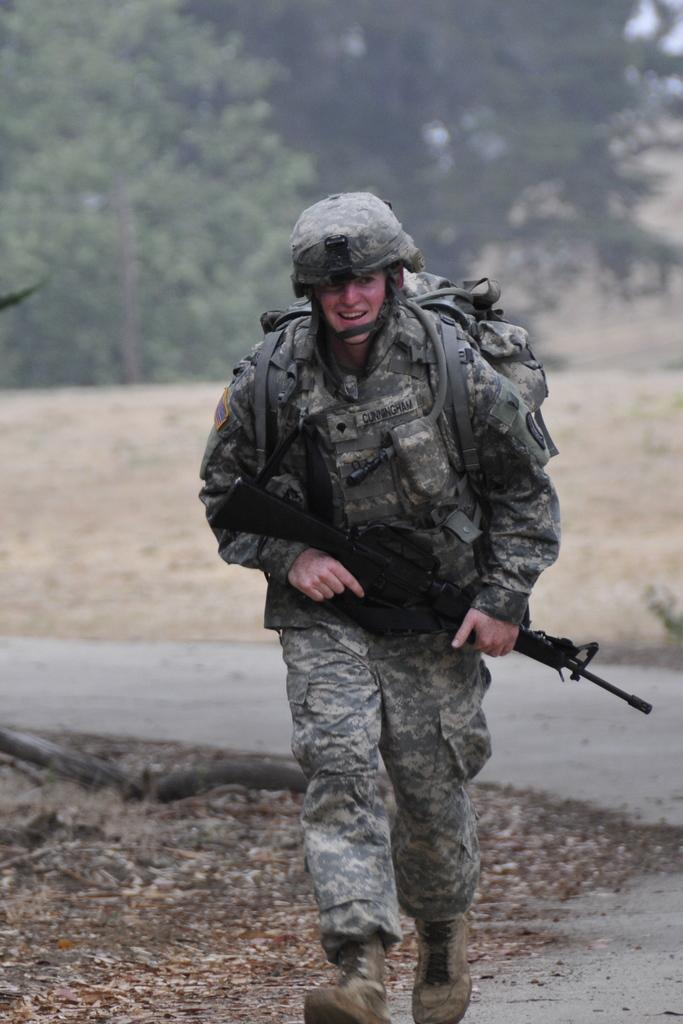What is the main subject of the image? There is a man in the image. What is the man doing in the image? The man is running in the image. What is the man holding in the image? The man is holding a gun in the image. What is the man wearing on his back in the image? The man is wearing a backpack in the image. What can be seen in the background of the image? There are trees in the background of the image. What type of addition problem can be solved using the numbers on the man's backpack? There are no numbers visible on the man's backpack in the image, so it is not possible to solve an addition problem using them. 